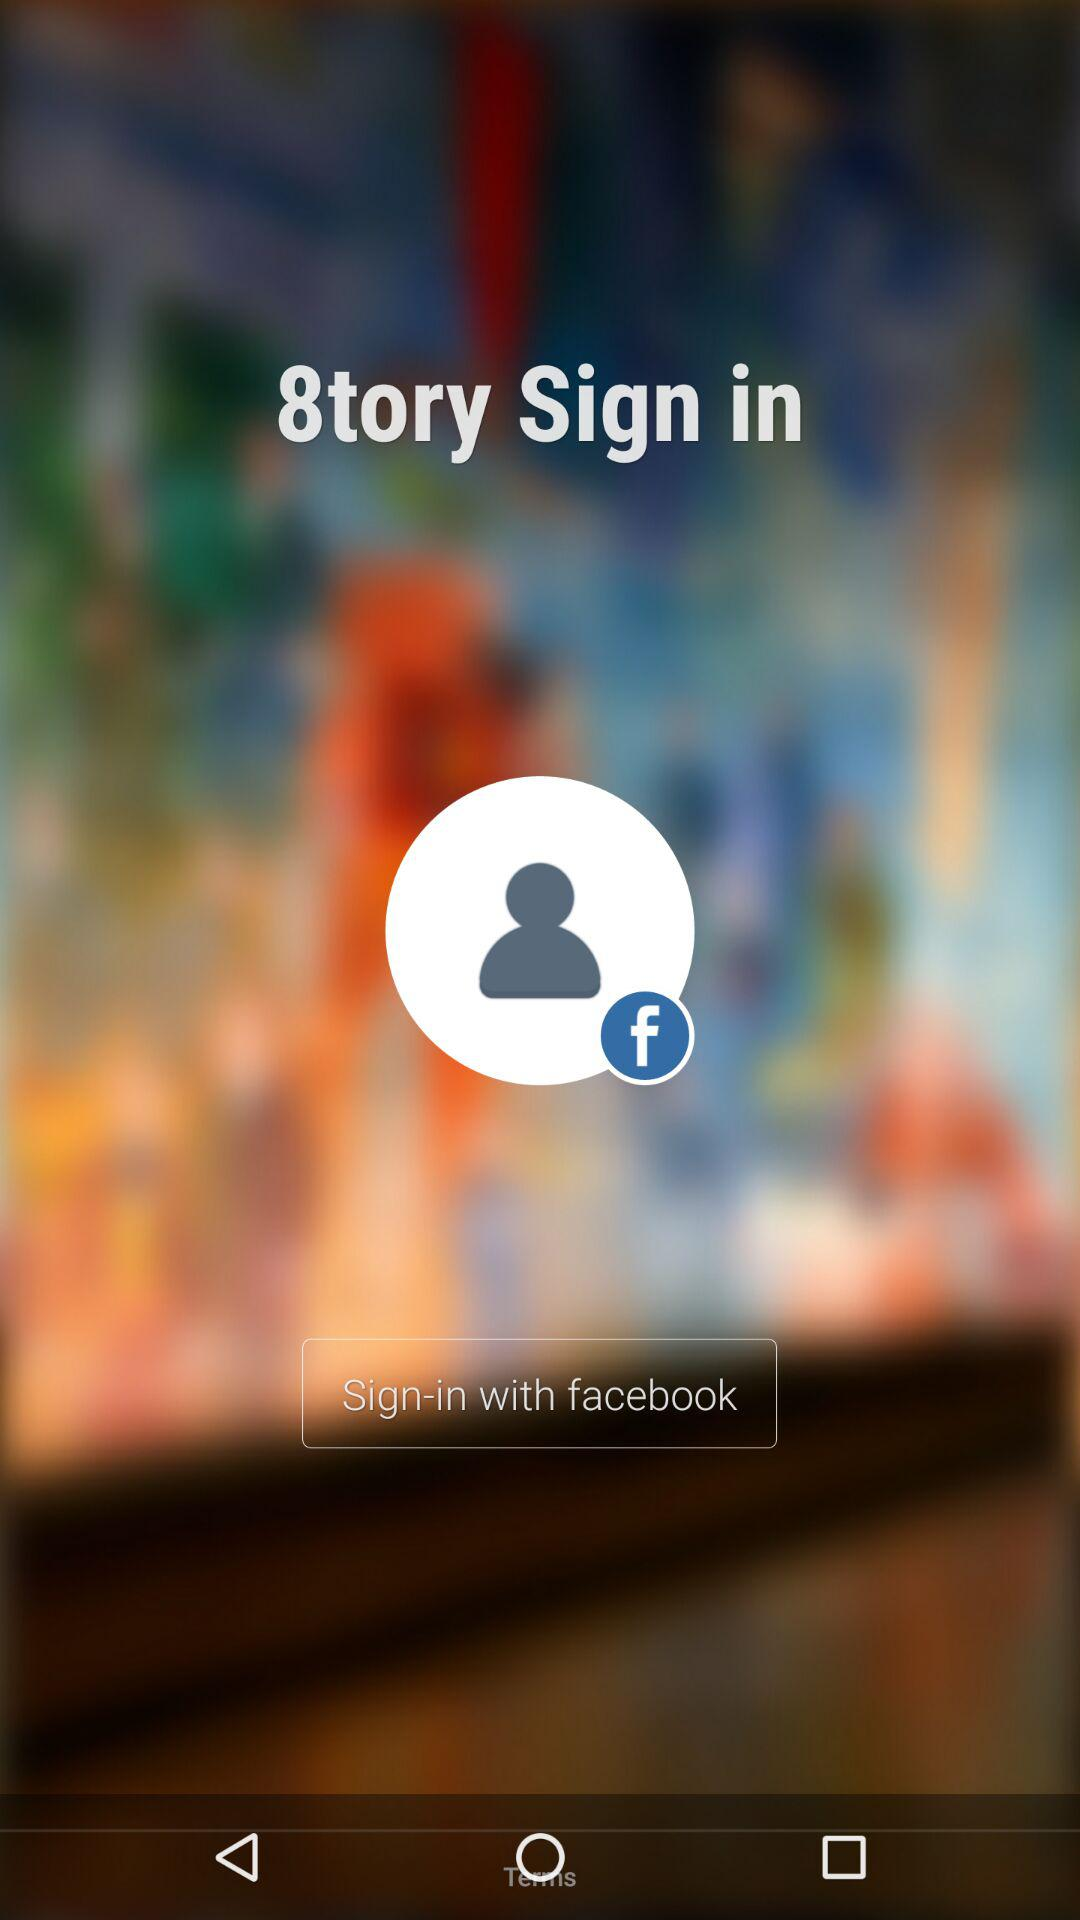What is the name of the application? The name of the application is "8tory". 